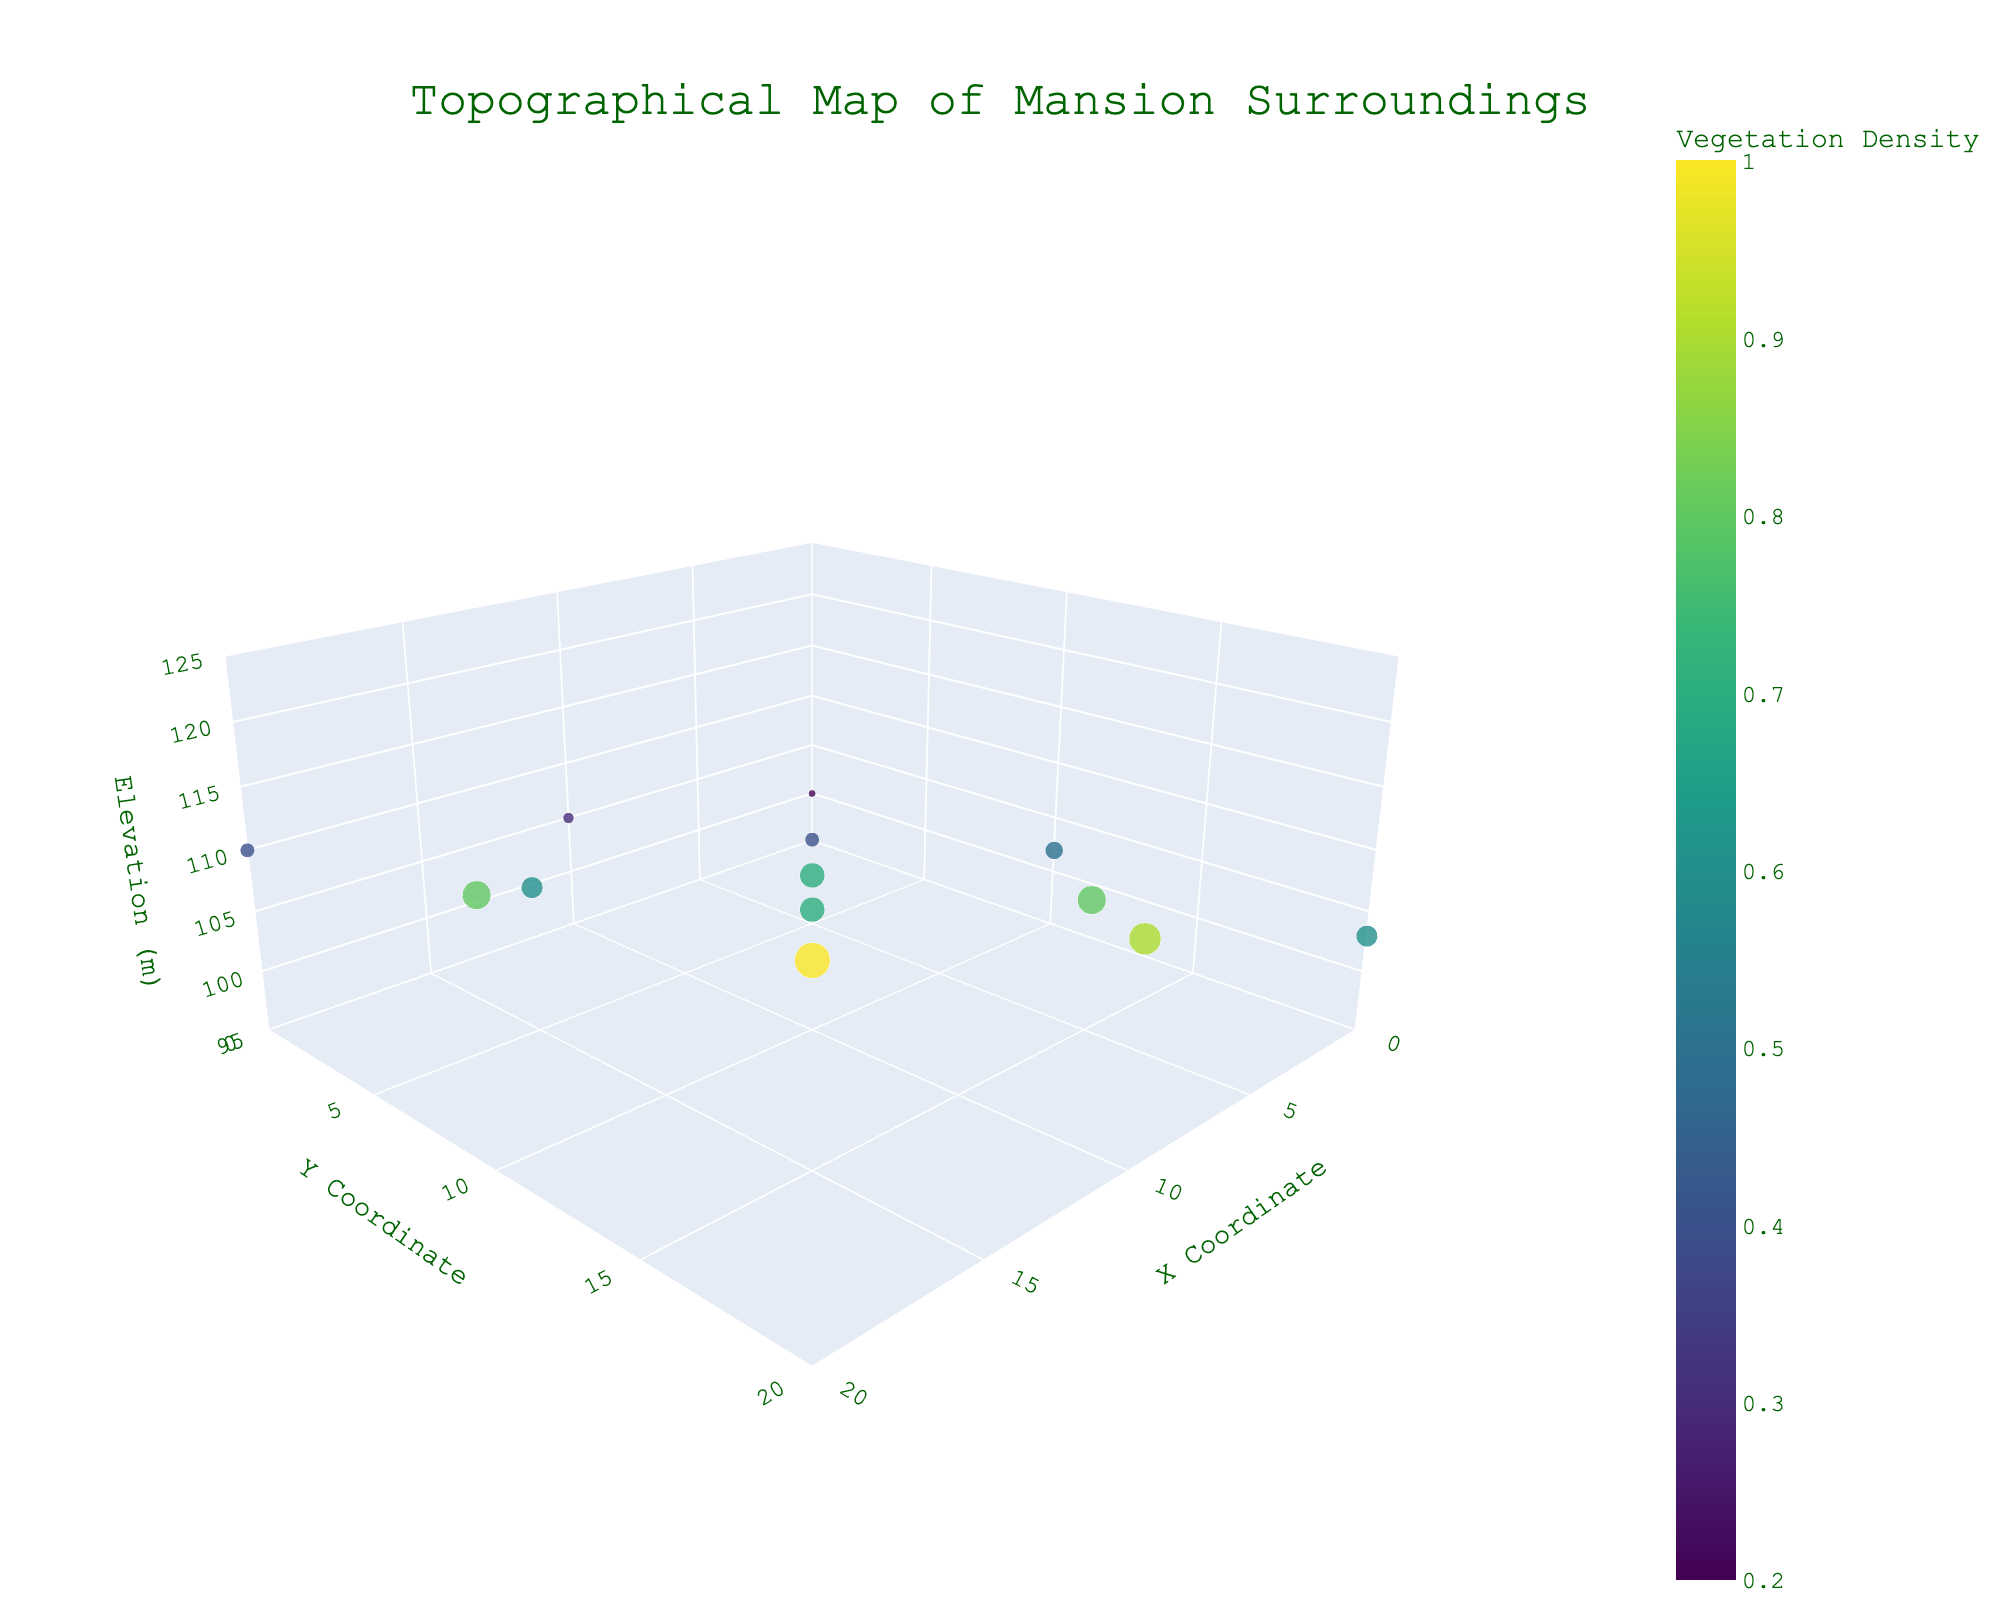what is the title of the 3d plot? The title is displayed prominently at the top-center of the plot.
Answer: Topographical Map of Mansion Surroundings How many data points are plotted in the 3d scatter plot? Counting each marker on the plot provides the total number of data points.
Answer: 13 What is the soil type at the highest elevation? The highest elevation corresponds to the point where the z-axis value is at its maximum.
Answer: Terra rossa What elevation corresponds to the lowest vegetation density? The vegetation density can be observed by the color and size of the markers, with the smallest size/least intense color indicating the lowest density.
Answer: 100 meters Compare the vegetation density between coordinates (10,10) and (20,20). Which one is higher? Vegetation density can be compared by examining the size and color of the corresponding markers.
Answer: (20,20) Which coordinate has the highest elevation? The coordinate with the maximum z-axis value has the highest elevation.
Answer: (20, 20) What is the aspect ratio of the plot? The aspect ratio is defined in the plot's layout settings for the x, y, and z dimensions.
Answer: x:1, y:1, z:0.5 Which data point corresponds to "Loamy sand" soil type? Hovering over the markers or referring to the textual information on them reveals the soil type.
Answer: (0,10) Calculate the average elevation of all data points. Sum all the elevation values and divide by the number of data points: (100+105+110+102+108+115+103+112+120+103+107+106+114)/13 = 106
Answer: 106 Which coordinate has both high elevation (above 110m) and high vegetation density (above 0.8)? Examine the plot for markers with the specified criteria in both z-axis and color/size.
Answer: (10,20) 